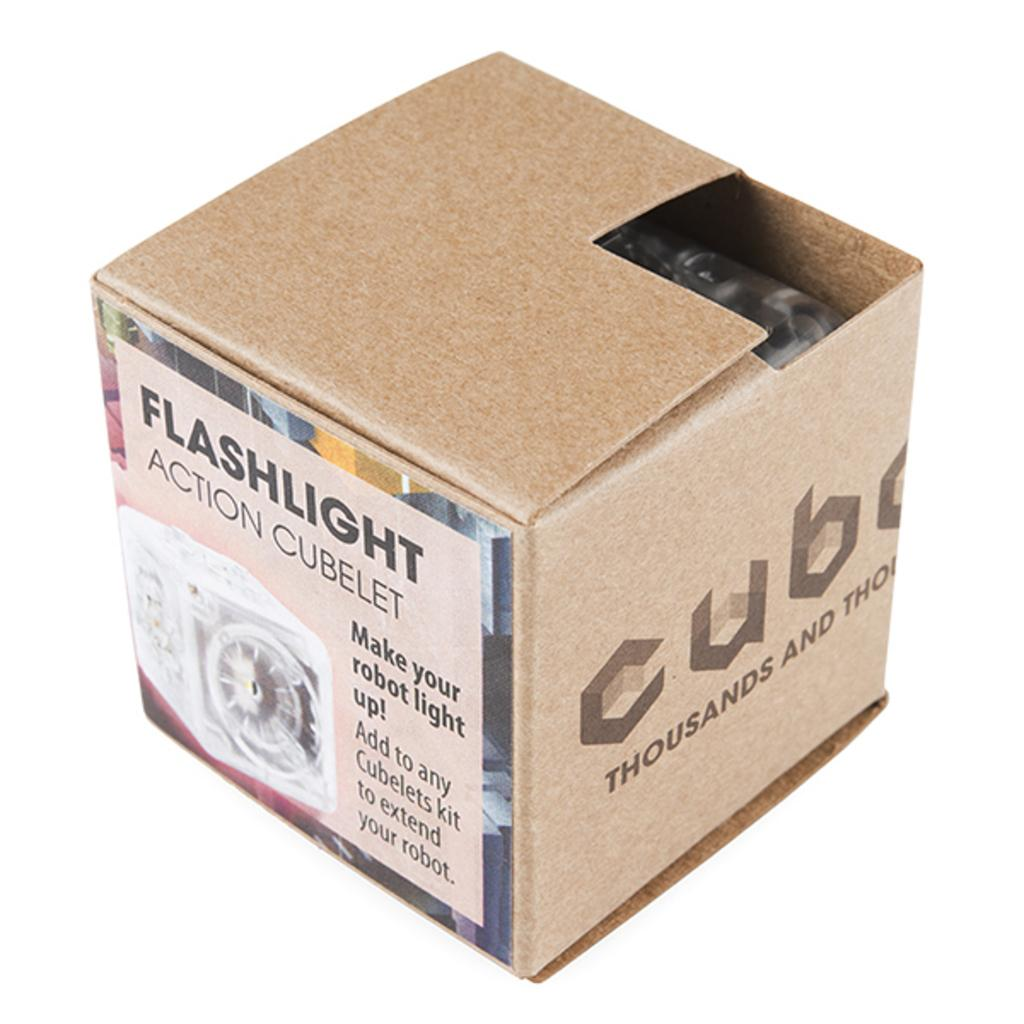<image>
Render a clear and concise summary of the photo. A box with a label that says Flashlight action cubelet 